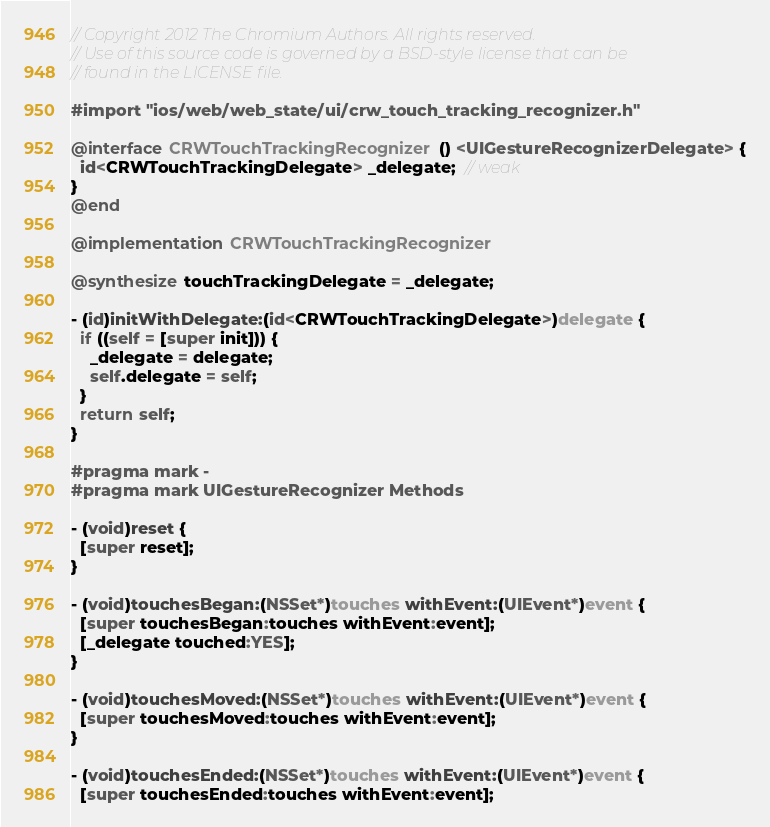Convert code to text. <code><loc_0><loc_0><loc_500><loc_500><_ObjectiveC_>// Copyright 2012 The Chromium Authors. All rights reserved.
// Use of this source code is governed by a BSD-style license that can be
// found in the LICENSE file.

#import "ios/web/web_state/ui/crw_touch_tracking_recognizer.h"

@interface CRWTouchTrackingRecognizer () <UIGestureRecognizerDelegate> {
  id<CRWTouchTrackingDelegate> _delegate;  // weak
}
@end

@implementation CRWTouchTrackingRecognizer

@synthesize touchTrackingDelegate = _delegate;

- (id)initWithDelegate:(id<CRWTouchTrackingDelegate>)delegate {
  if ((self = [super init])) {
    _delegate = delegate;
    self.delegate = self;
  }
  return self;
}

#pragma mark -
#pragma mark UIGestureRecognizer Methods

- (void)reset {
  [super reset];
}

- (void)touchesBegan:(NSSet*)touches withEvent:(UIEvent*)event {
  [super touchesBegan:touches withEvent:event];
  [_delegate touched:YES];
}

- (void)touchesMoved:(NSSet*)touches withEvent:(UIEvent*)event {
  [super touchesMoved:touches withEvent:event];
}

- (void)touchesEnded:(NSSet*)touches withEvent:(UIEvent*)event {
  [super touchesEnded:touches withEvent:event];</code> 